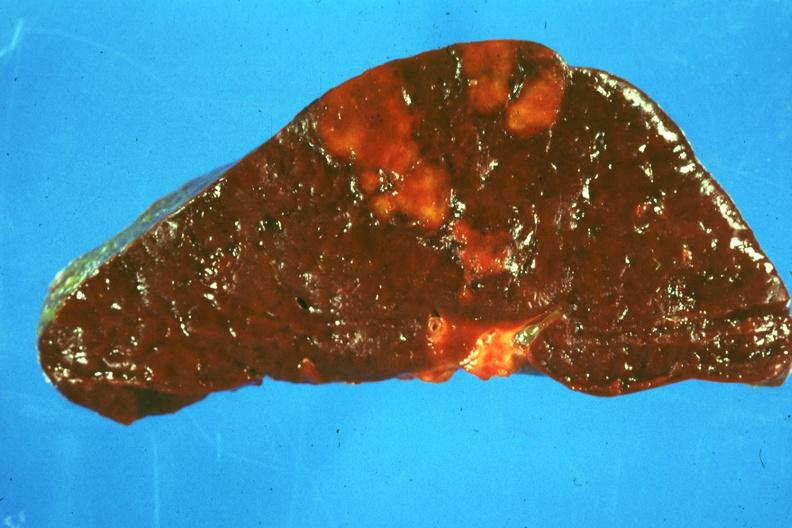where is this part in?
Answer the question using a single word or phrase. Spleen 